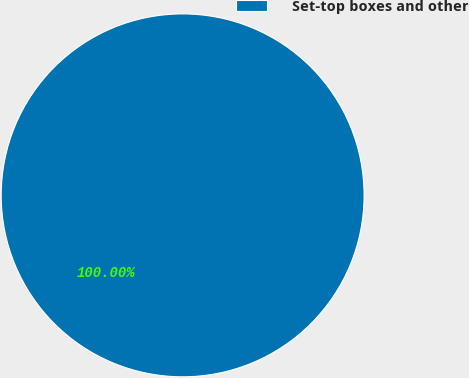Convert chart. <chart><loc_0><loc_0><loc_500><loc_500><pie_chart><fcel>Set-top boxes and other<nl><fcel>100.0%<nl></chart> 